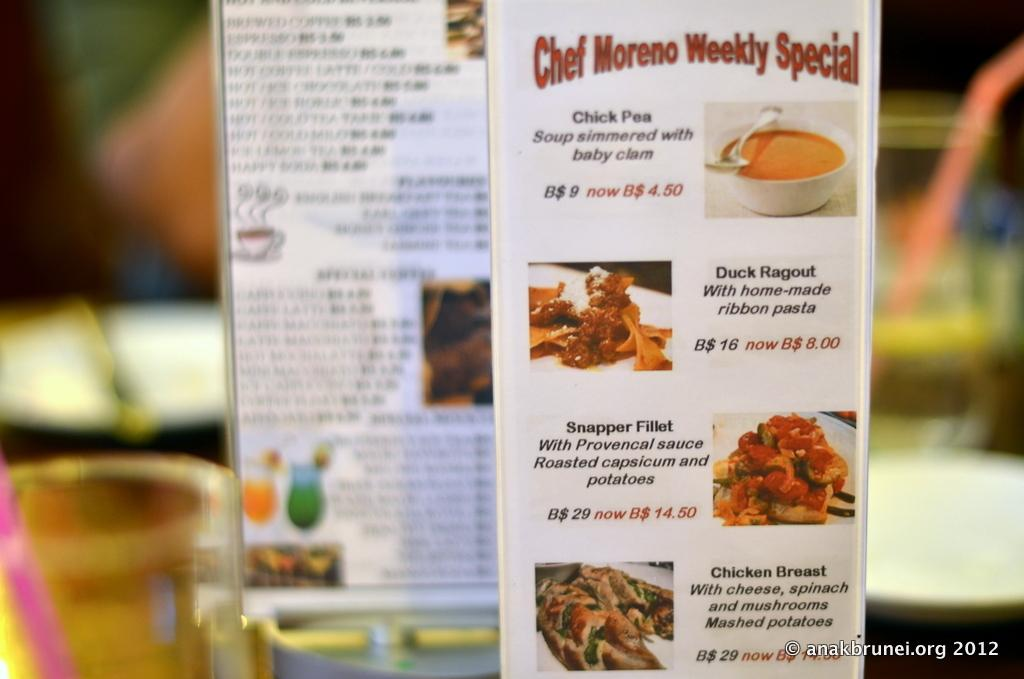<image>
Give a short and clear explanation of the subsequent image. A menu sitting on a table with the label Chef Moreno Weekly Special. 